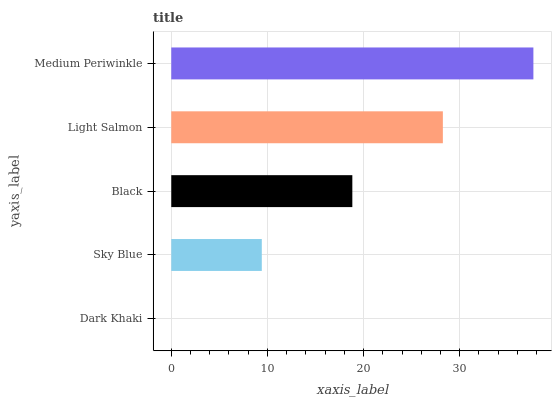Is Dark Khaki the minimum?
Answer yes or no. Yes. Is Medium Periwinkle the maximum?
Answer yes or no. Yes. Is Sky Blue the minimum?
Answer yes or no. No. Is Sky Blue the maximum?
Answer yes or no. No. Is Sky Blue greater than Dark Khaki?
Answer yes or no. Yes. Is Dark Khaki less than Sky Blue?
Answer yes or no. Yes. Is Dark Khaki greater than Sky Blue?
Answer yes or no. No. Is Sky Blue less than Dark Khaki?
Answer yes or no. No. Is Black the high median?
Answer yes or no. Yes. Is Black the low median?
Answer yes or no. Yes. Is Dark Khaki the high median?
Answer yes or no. No. Is Medium Periwinkle the low median?
Answer yes or no. No. 